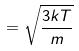Convert formula to latex. <formula><loc_0><loc_0><loc_500><loc_500>= \sqrt { \frac { 3 k T } { m } }</formula> 